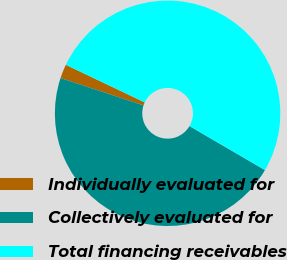<chart> <loc_0><loc_0><loc_500><loc_500><pie_chart><fcel>Individually evaluated for<fcel>Collectively evaluated for<fcel>Total financing receivables<nl><fcel>2.02%<fcel>46.66%<fcel>51.32%<nl></chart> 